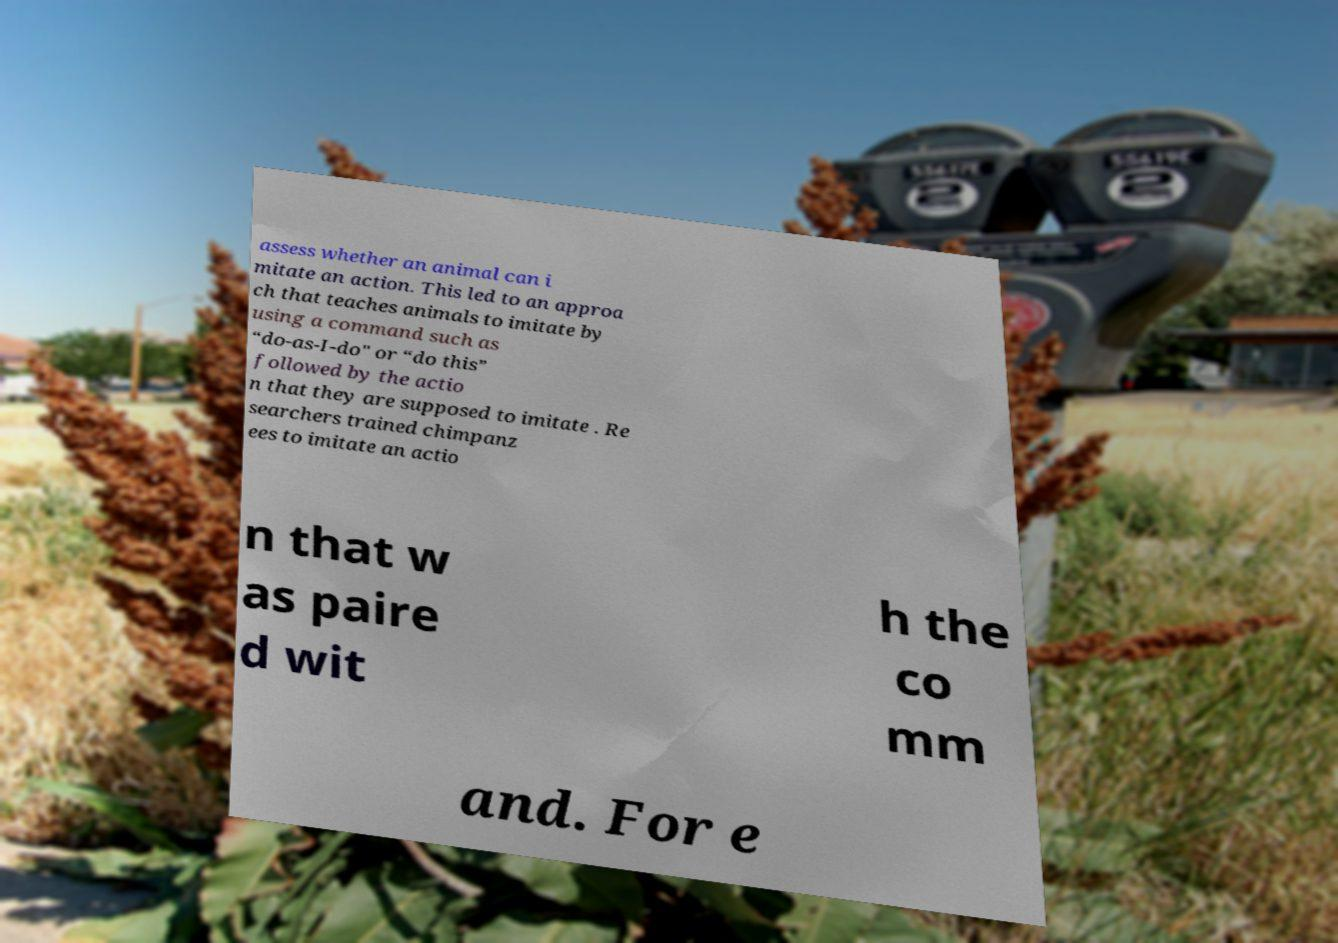For documentation purposes, I need the text within this image transcribed. Could you provide that? assess whether an animal can i mitate an action. This led to an approa ch that teaches animals to imitate by using a command such as “do-as-I-do" or “do this” followed by the actio n that they are supposed to imitate . Re searchers trained chimpanz ees to imitate an actio n that w as paire d wit h the co mm and. For e 